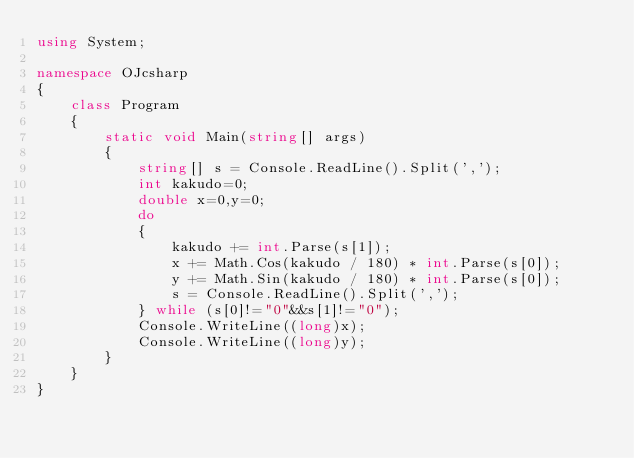<code> <loc_0><loc_0><loc_500><loc_500><_C#_>using System;

namespace OJcsharp
{
    class Program
    {
        static void Main(string[] args)
        {
            string[] s = Console.ReadLine().Split(',');
            int kakudo=0;
            double x=0,y=0;
            do
            {
                kakudo += int.Parse(s[1]);
                x += Math.Cos(kakudo / 180) * int.Parse(s[0]);
                y += Math.Sin(kakudo / 180) * int.Parse(s[0]);
                s = Console.ReadLine().Split(',');
            } while (s[0]!="0"&&s[1]!="0");
            Console.WriteLine((long)x);
            Console.WriteLine((long)y);
        }
    }
}</code> 